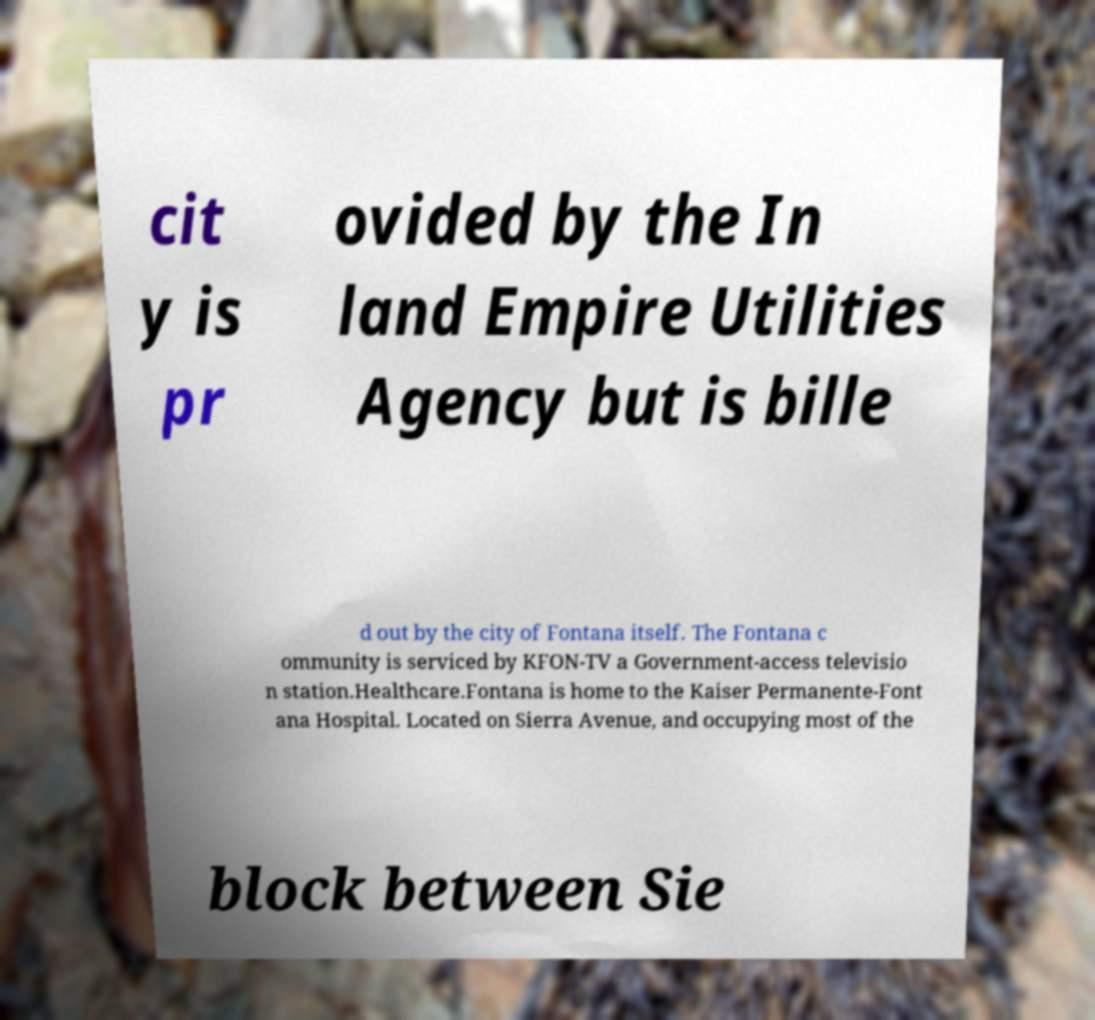Could you extract and type out the text from this image? cit y is pr ovided by the In land Empire Utilities Agency but is bille d out by the city of Fontana itself. The Fontana c ommunity is serviced by KFON-TV a Government-access televisio n station.Healthcare.Fontana is home to the Kaiser Permanente-Font ana Hospital. Located on Sierra Avenue, and occupying most of the block between Sie 